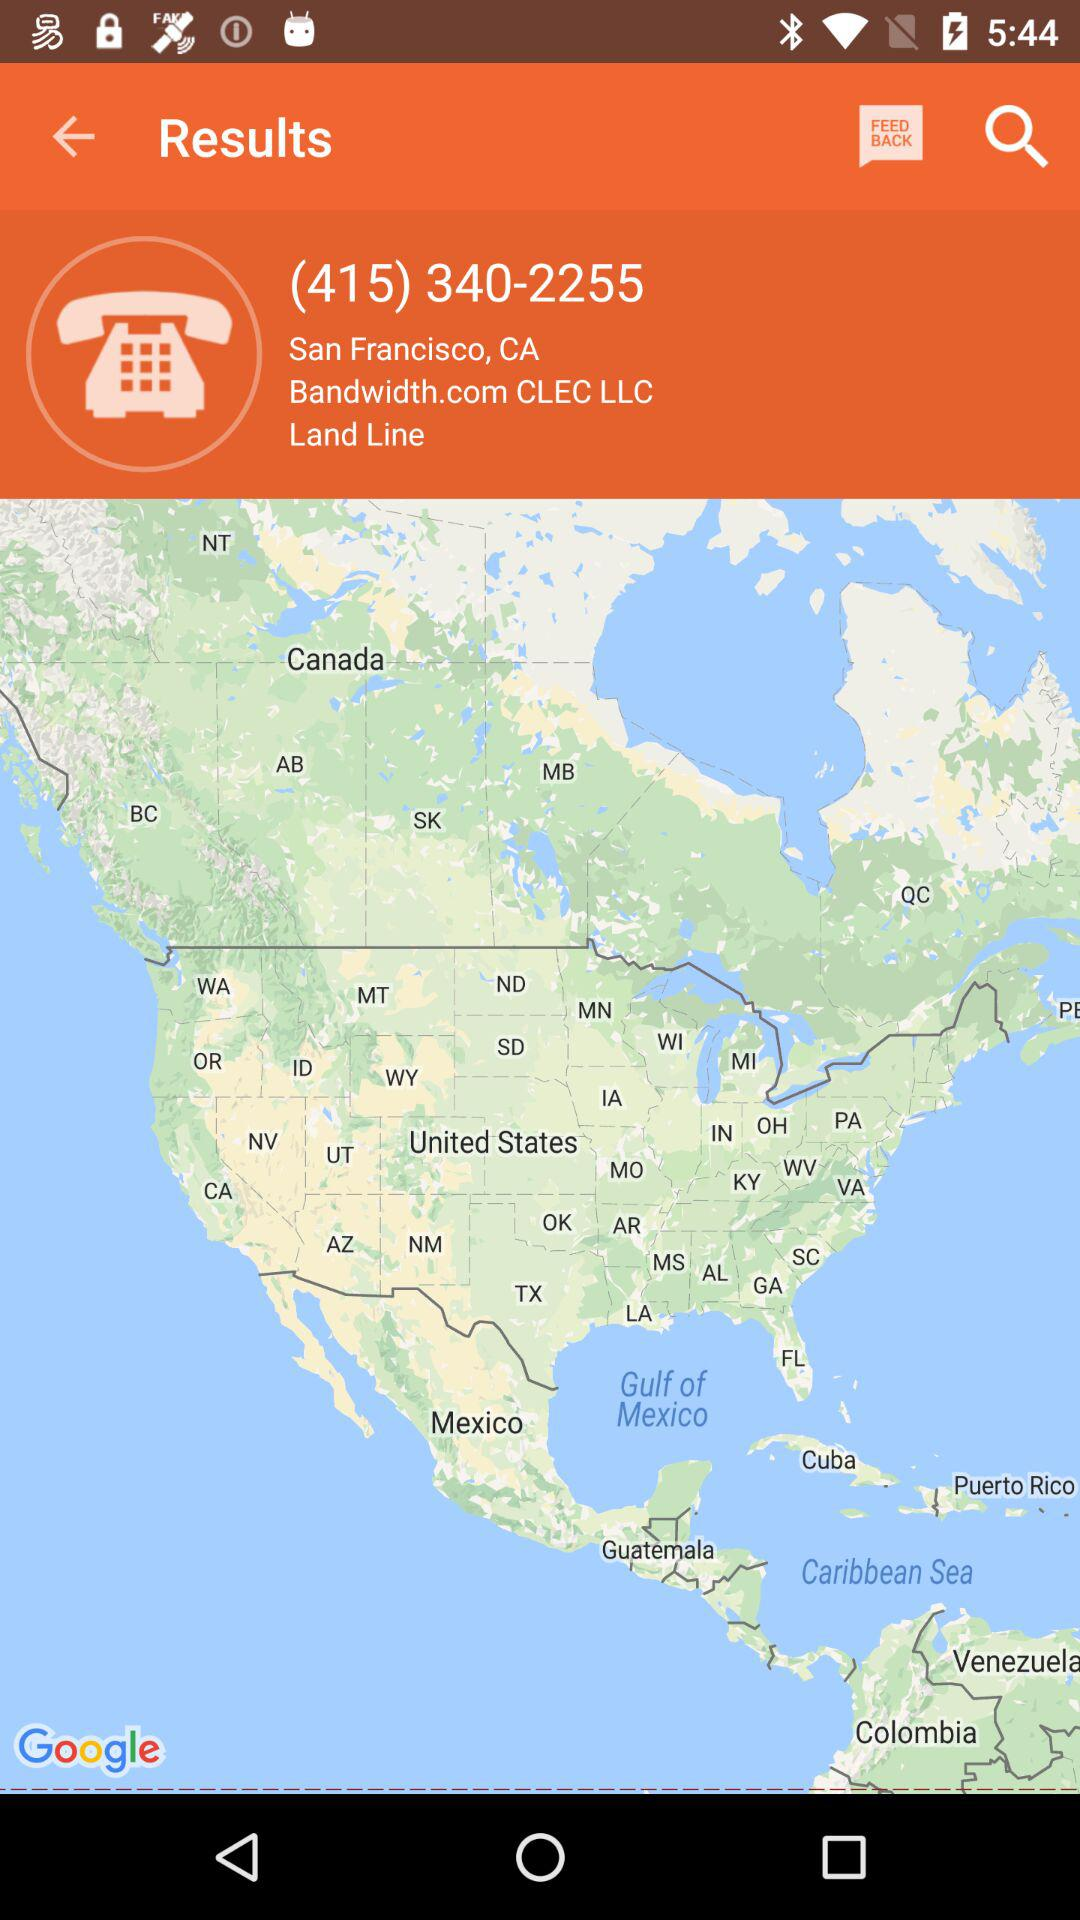What is the location? The location is "San Francisco, CA". 